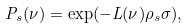<formula> <loc_0><loc_0><loc_500><loc_500>P _ { s } ( \nu ) = \exp ( - L ( \nu ) \rho _ { s } \sigma ) ,</formula> 